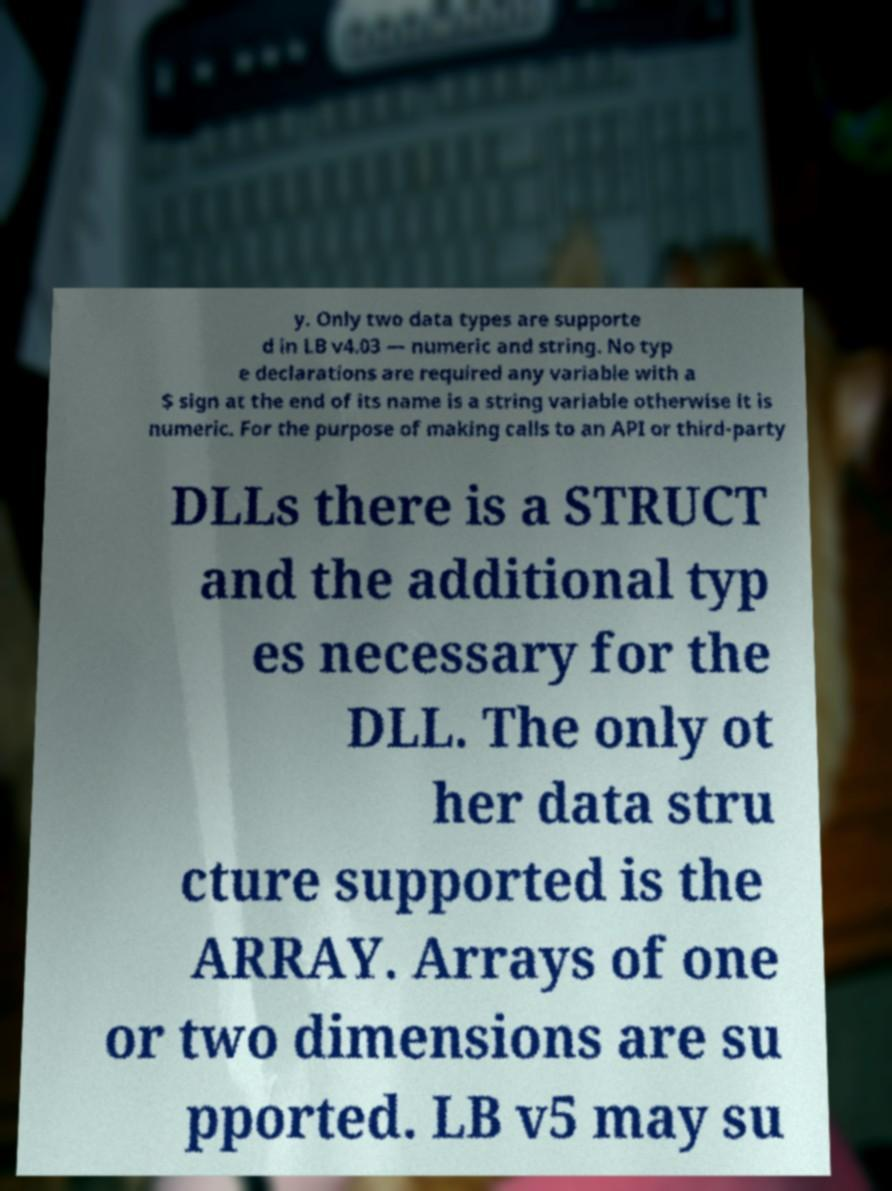Could you assist in decoding the text presented in this image and type it out clearly? y. Only two data types are supporte d in LB v4.03 — numeric and string. No typ e declarations are required any variable with a $ sign at the end of its name is a string variable otherwise it is numeric. For the purpose of making calls to an API or third-party DLLs there is a STRUCT and the additional typ es necessary for the DLL. The only ot her data stru cture supported is the ARRAY. Arrays of one or two dimensions are su pported. LB v5 may su 